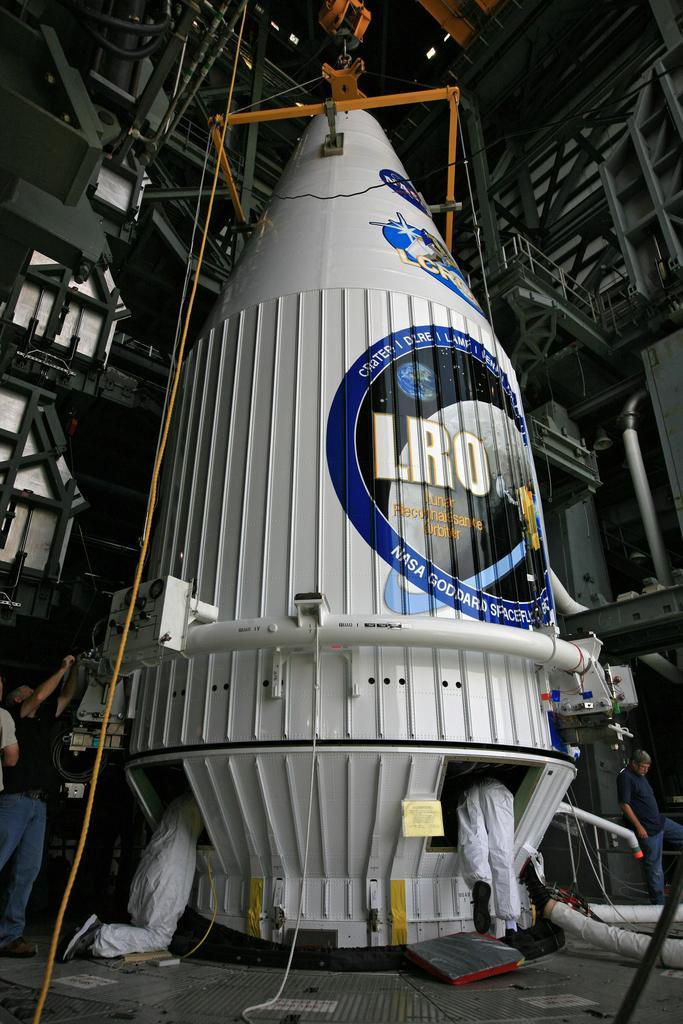What is the main subject of the image? The main subject of the image is a spaceship. What are the people in the image doing? The people in the image are working on the spaceship. What type of oranges can be seen growing on the spaceship in the image? There are no oranges present in the image, as it features a spaceship and people working on it. What type of drug can be seen being administered to the boy in the image? There is no boy or drug present in the image; it features a spaceship and people working on it. 